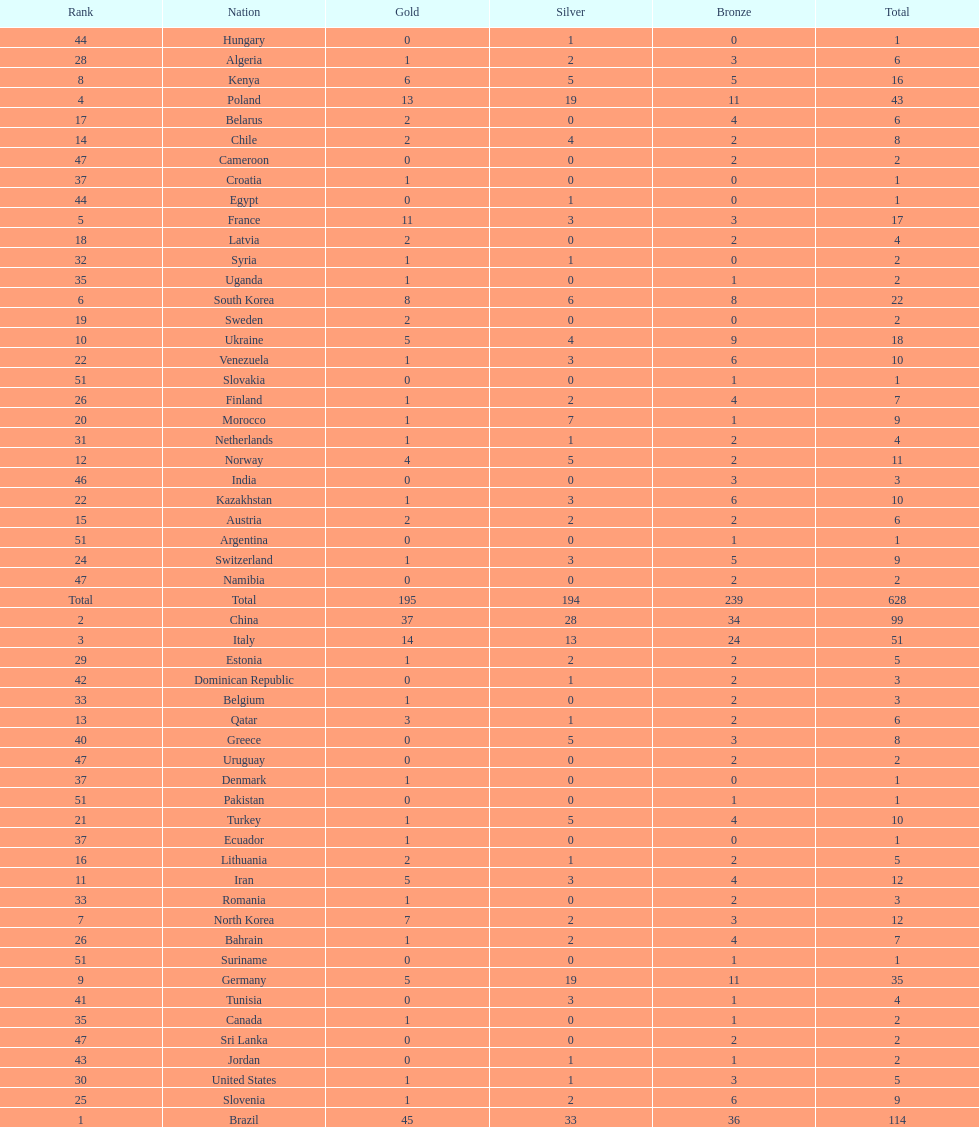How many cumulative medals has norway won? 11. Parse the full table. {'header': ['Rank', 'Nation', 'Gold', 'Silver', 'Bronze', 'Total'], 'rows': [['44', 'Hungary', '0', '1', '0', '1'], ['28', 'Algeria', '1', '2', '3', '6'], ['8', 'Kenya', '6', '5', '5', '16'], ['4', 'Poland', '13', '19', '11', '43'], ['17', 'Belarus', '2', '0', '4', '6'], ['14', 'Chile', '2', '4', '2', '8'], ['47', 'Cameroon', '0', '0', '2', '2'], ['37', 'Croatia', '1', '0', '0', '1'], ['44', 'Egypt', '0', '1', '0', '1'], ['5', 'France', '11', '3', '3', '17'], ['18', 'Latvia', '2', '0', '2', '4'], ['32', 'Syria', '1', '1', '0', '2'], ['35', 'Uganda', '1', '0', '1', '2'], ['6', 'South Korea', '8', '6', '8', '22'], ['19', 'Sweden', '2', '0', '0', '2'], ['10', 'Ukraine', '5', '4', '9', '18'], ['22', 'Venezuela', '1', '3', '6', '10'], ['51', 'Slovakia', '0', '0', '1', '1'], ['26', 'Finland', '1', '2', '4', '7'], ['20', 'Morocco', '1', '7', '1', '9'], ['31', 'Netherlands', '1', '1', '2', '4'], ['12', 'Norway', '4', '5', '2', '11'], ['46', 'India', '0', '0', '3', '3'], ['22', 'Kazakhstan', '1', '3', '6', '10'], ['15', 'Austria', '2', '2', '2', '6'], ['51', 'Argentina', '0', '0', '1', '1'], ['24', 'Switzerland', '1', '3', '5', '9'], ['47', 'Namibia', '0', '0', '2', '2'], ['Total', 'Total', '195', '194', '239', '628'], ['2', 'China', '37', '28', '34', '99'], ['3', 'Italy', '14', '13', '24', '51'], ['29', 'Estonia', '1', '2', '2', '5'], ['42', 'Dominican Republic', '0', '1', '2', '3'], ['33', 'Belgium', '1', '0', '2', '3'], ['13', 'Qatar', '3', '1', '2', '6'], ['40', 'Greece', '0', '5', '3', '8'], ['47', 'Uruguay', '0', '0', '2', '2'], ['37', 'Denmark', '1', '0', '0', '1'], ['51', 'Pakistan', '0', '0', '1', '1'], ['21', 'Turkey', '1', '5', '4', '10'], ['37', 'Ecuador', '1', '0', '0', '1'], ['16', 'Lithuania', '2', '1', '2', '5'], ['11', 'Iran', '5', '3', '4', '12'], ['33', 'Romania', '1', '0', '2', '3'], ['7', 'North Korea', '7', '2', '3', '12'], ['26', 'Bahrain', '1', '2', '4', '7'], ['51', 'Suriname', '0', '0', '1', '1'], ['9', 'Germany', '5', '19', '11', '35'], ['41', 'Tunisia', '0', '3', '1', '4'], ['35', 'Canada', '1', '0', '1', '2'], ['47', 'Sri Lanka', '0', '0', '2', '2'], ['43', 'Jordan', '0', '1', '1', '2'], ['30', 'United States', '1', '1', '3', '5'], ['25', 'Slovenia', '1', '2', '6', '9'], ['1', 'Brazil', '45', '33', '36', '114']]} 